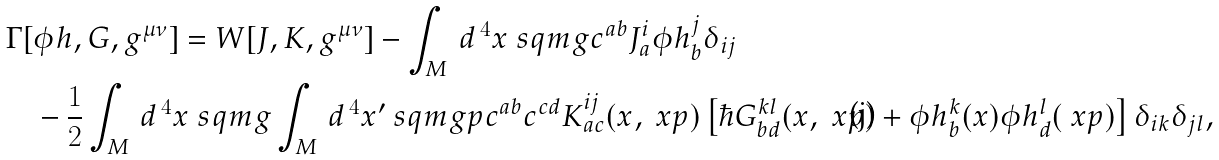<formula> <loc_0><loc_0><loc_500><loc_500>\Gamma [ & \phi h , G , g ^ { \mu \nu } ] = W [ J , K , g ^ { \mu \nu } ] - \int _ { M } \, d ^ { \, 4 } x \ s q m g c ^ { a b } J ^ { i } _ { a } \phi h ^ { j } _ { b } \delta _ { i j } \\ & - \frac { 1 } { 2 } \int _ { M } \, d ^ { \, 4 } x \ s q m g \int _ { M } \, d ^ { \, 4 } x ^ { \prime } \ s q m g p c ^ { a b } c ^ { c d } K ^ { i j } _ { a c } ( x , \ x p ) \left [ \hbar { G } ^ { k l } _ { b d } ( x , \ x p ) + \phi h ^ { k } _ { b } ( x ) \phi h ^ { l } _ { d } ( \ x p ) \right ] \delta _ { i k } \delta _ { j l } ,</formula> 